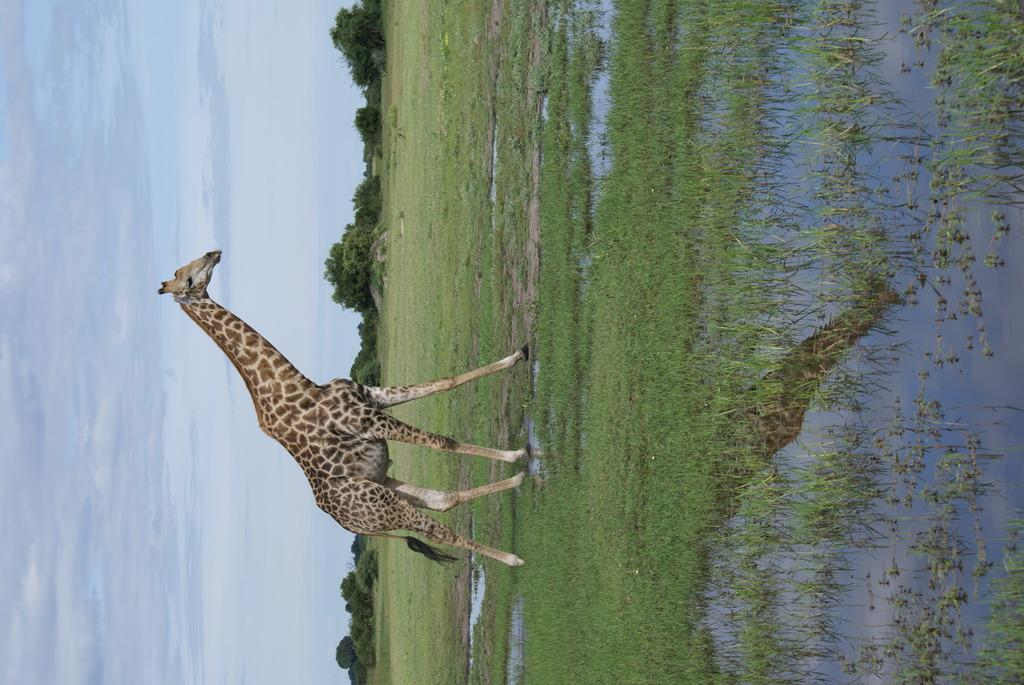What can be seen towards the left of the image? The sky is visible towards the left of the image. What type of vegetation is present in the image? There are trees in the image, and there is also grass. What animal is featured in the image? There is a giraffe in the image. What is visible towards the right of the image? There is water visible towards the right of the image. What type of milk does the giraffe drink in the image? There is no indication in the image that the giraffe is drinking milk, and therefore we cannot determine the type of milk it might be consuming. 